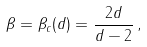Convert formula to latex. <formula><loc_0><loc_0><loc_500><loc_500>\beta = \beta _ { c } ( d ) = \frac { 2 d } { d - 2 } \, ,</formula> 